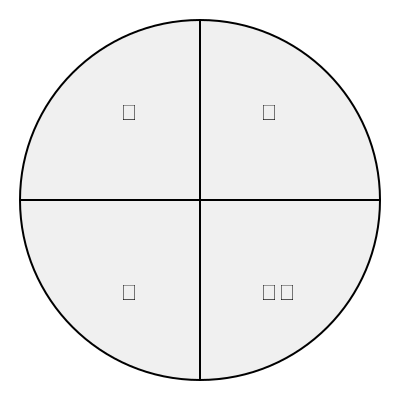Which of the four music genre icons or symbols in the diagram would be most relevant for a producer seeking placement in a jazz-themed commercial? To determine the most relevant icon for a jazz-themed commercial, let's analyze each symbol:

1. 🎸 (Guitar): While guitars are used in jazz, they are more commonly associated with rock, blues, or country music.

2. 🎷 (Saxophone): The saxophone is a quintessential jazz instrument, often featured prominently in jazz compositions and performances.

3. 🎵 (Musical note): This is a general symbol for music and could represent any genre.

4. 🎚️ (Mixing board fader): This represents audio production equipment, which is used across all genres.

For a jazz-themed commercial, the saxophone (🎷) would be the most iconic and immediately recognizable symbol. It strongly evokes the sound and style of jazz music, making it the best choice for a producer seeking placement in a jazz-themed commercial.
Answer: 🎷 (Saxophone) 